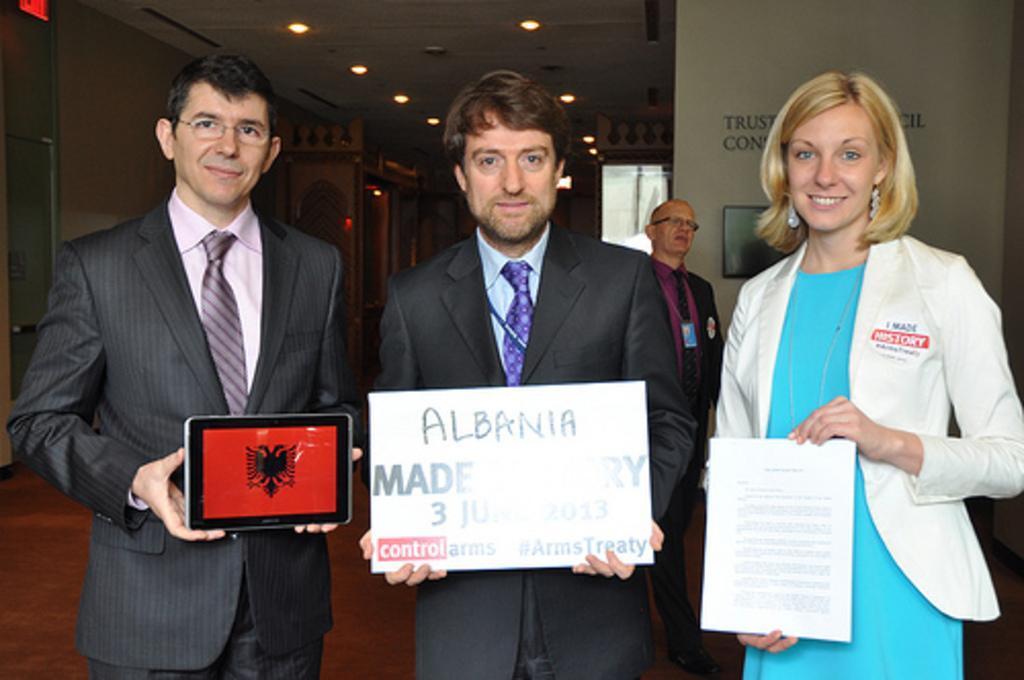Describe this image in one or two sentences. In the image we can see there are people standing in front and holding paper, banner and tablet in their hand. Men are wearing formal suits and behind there is another man standing and he is wearing id card in his neck. There are lightings on the top. 